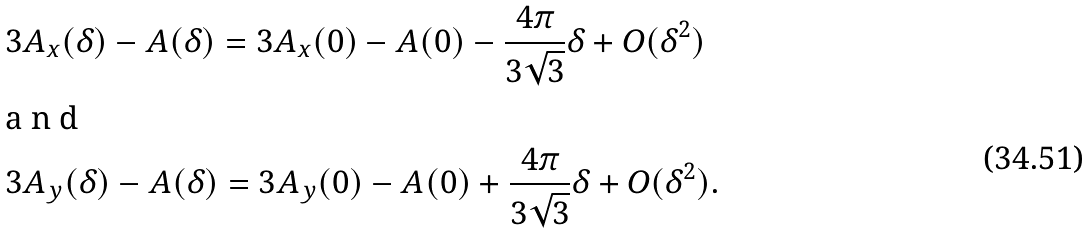Convert formula to latex. <formula><loc_0><loc_0><loc_500><loc_500>& 3 A _ { x } ( \delta ) - A ( \delta ) = 3 A _ { x } ( 0 ) - A ( 0 ) - \frac { 4 \pi } { 3 \sqrt { 3 } } \delta + O ( \delta ^ { 2 } ) \intertext { a n d } & 3 A _ { y } ( \delta ) - A ( \delta ) = 3 A _ { y } ( 0 ) - A ( 0 ) + \frac { 4 \pi } { 3 \sqrt { 3 } } \delta + O ( \delta ^ { 2 } ) .</formula> 